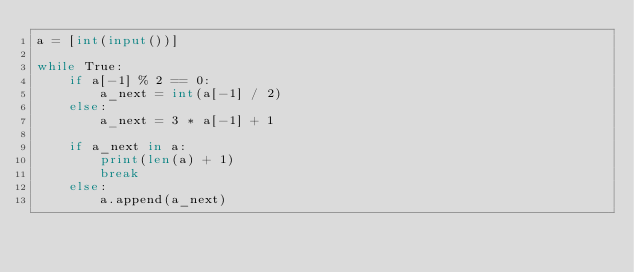Convert code to text. <code><loc_0><loc_0><loc_500><loc_500><_Python_>a = [int(input())]

while True:
    if a[-1] % 2 == 0:
        a_next = int(a[-1] / 2)
    else:
        a_next = 3 * a[-1] + 1
    
    if a_next in a:
        print(len(a) + 1)
        break
    else:
        a.append(a_next)</code> 